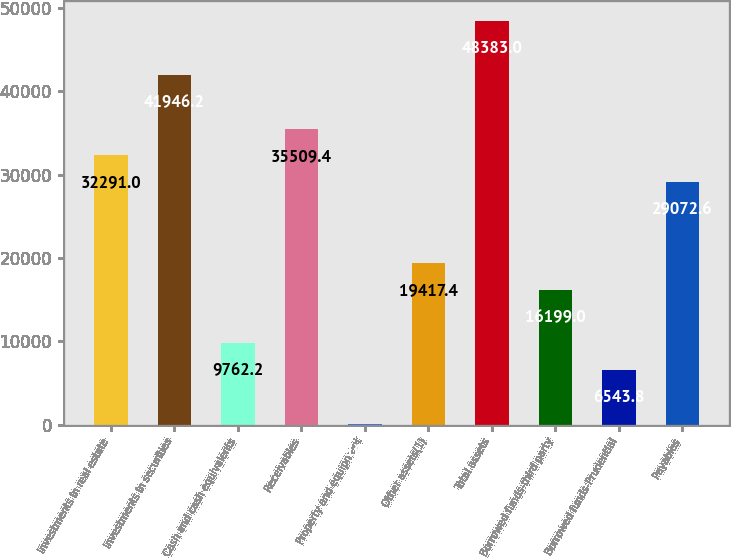<chart> <loc_0><loc_0><loc_500><loc_500><bar_chart><fcel>Investments in real estate<fcel>Investments in securities<fcel>Cash and cash equivalents<fcel>Receivables<fcel>Property and equipment<fcel>Other assets(1)<fcel>Total assets<fcel>Borrowed funds-third party<fcel>Borrowed funds-Prudential<fcel>Payables<nl><fcel>32291<fcel>41946.2<fcel>9762.2<fcel>35509.4<fcel>107<fcel>19417.4<fcel>48383<fcel>16199<fcel>6543.8<fcel>29072.6<nl></chart> 